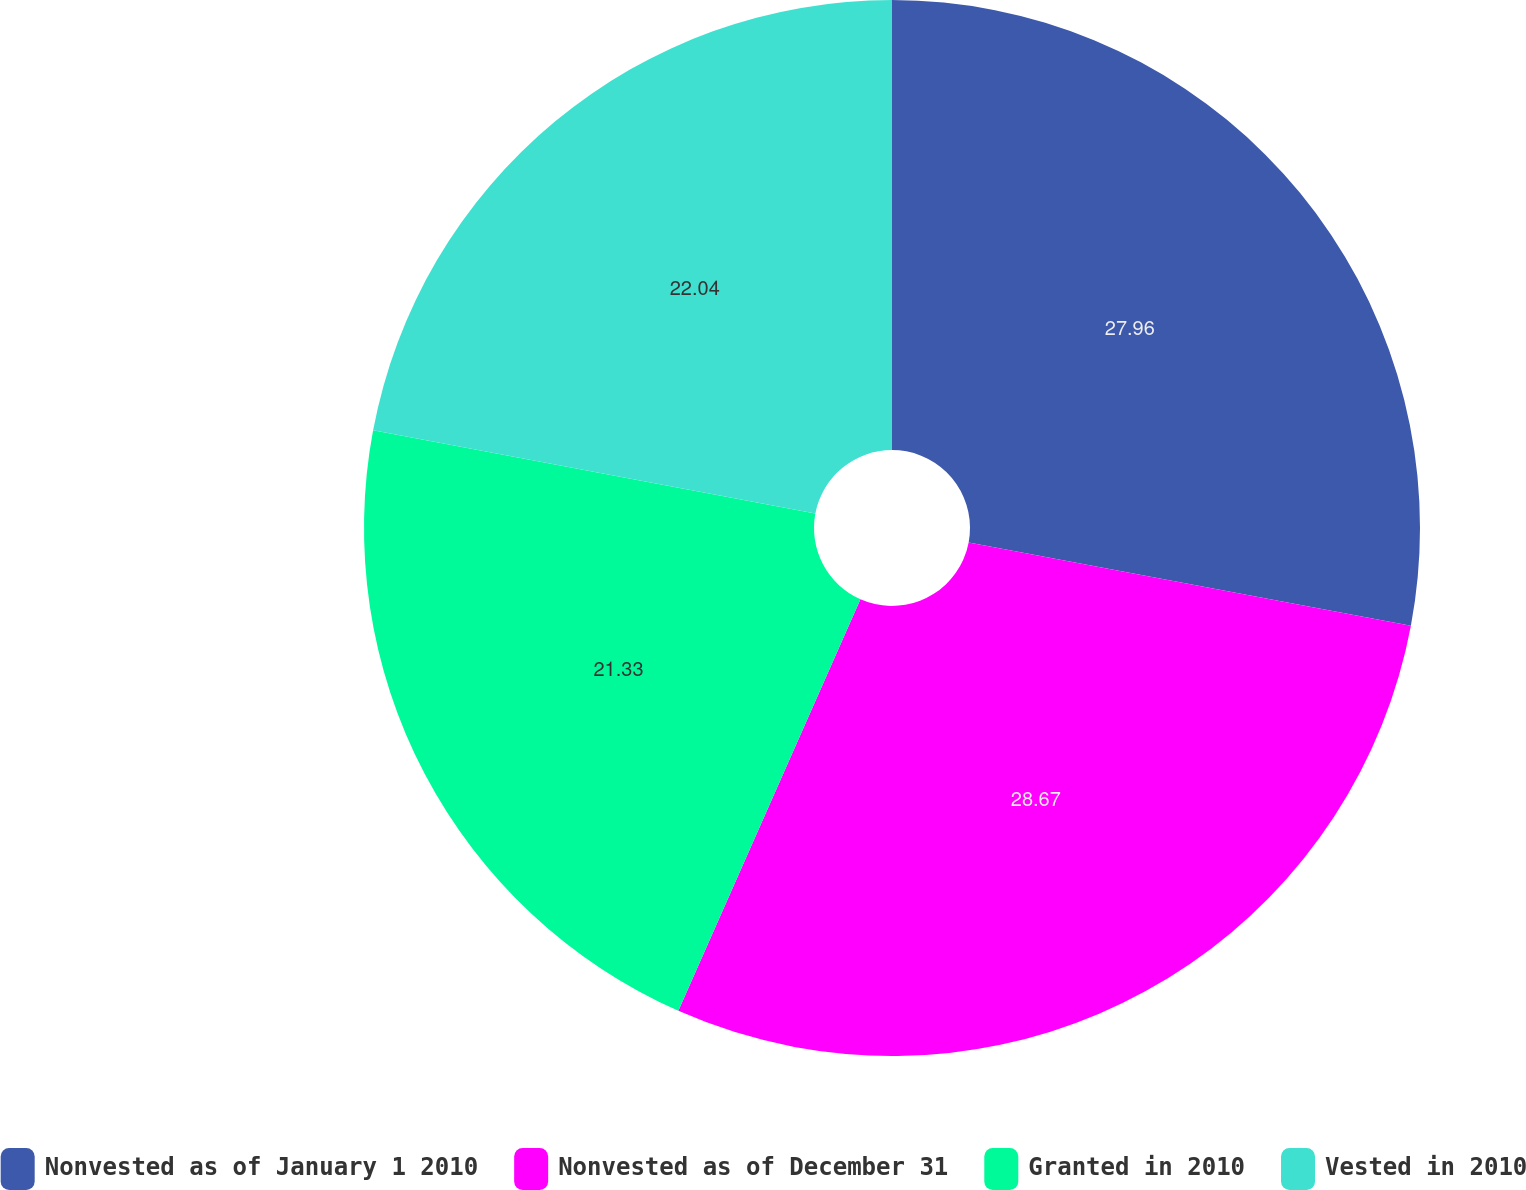Convert chart. <chart><loc_0><loc_0><loc_500><loc_500><pie_chart><fcel>Nonvested as of January 1 2010<fcel>Nonvested as of December 31<fcel>Granted in 2010<fcel>Vested in 2010<nl><fcel>27.96%<fcel>28.67%<fcel>21.33%<fcel>22.04%<nl></chart> 